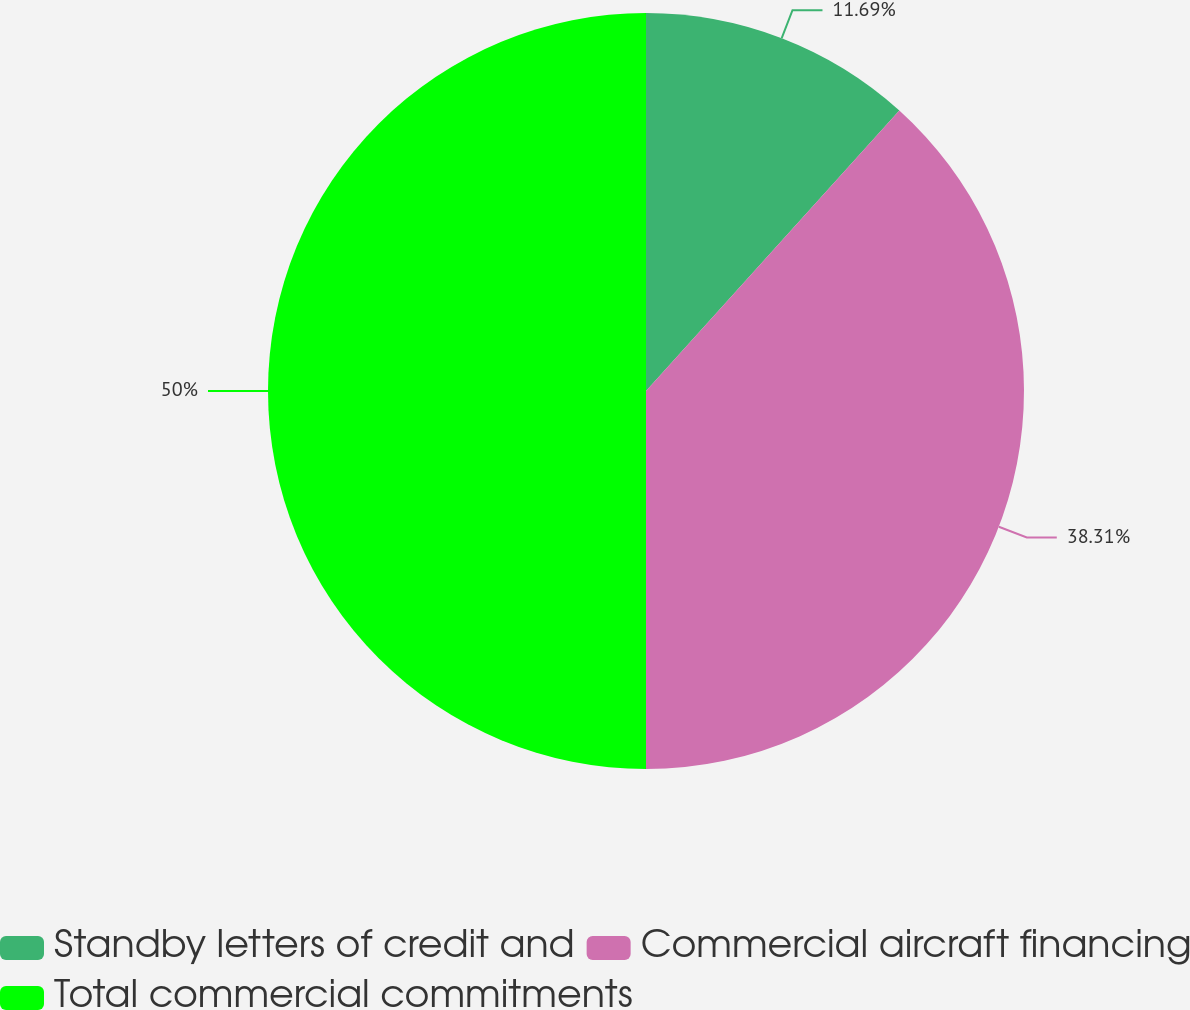<chart> <loc_0><loc_0><loc_500><loc_500><pie_chart><fcel>Standby letters of credit and<fcel>Commercial aircraft financing<fcel>Total commercial commitments<nl><fcel>11.69%<fcel>38.31%<fcel>50.0%<nl></chart> 